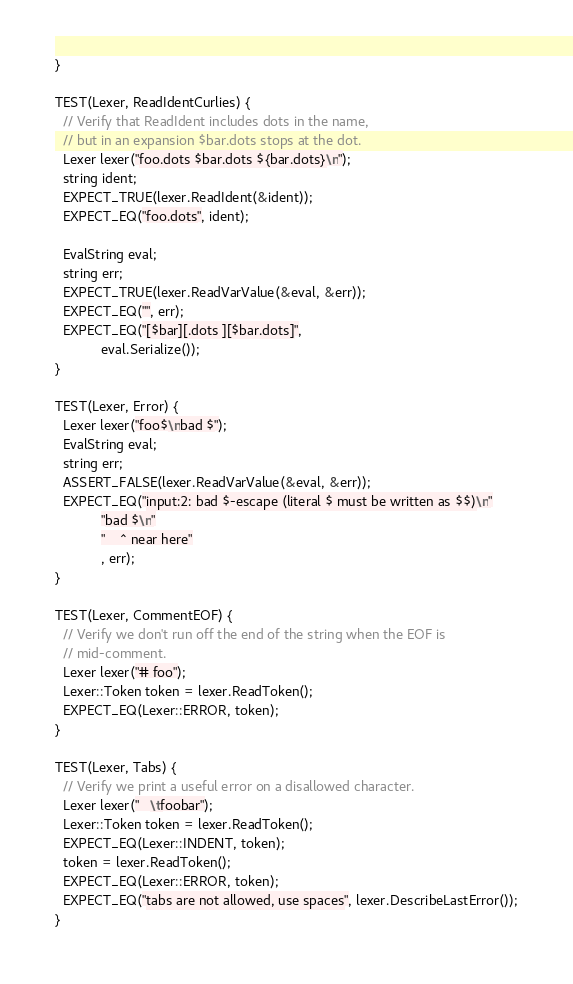Convert code to text. <code><loc_0><loc_0><loc_500><loc_500><_C++_>}

TEST(Lexer, ReadIdentCurlies) {
  // Verify that ReadIdent includes dots in the name,
  // but in an expansion $bar.dots stops at the dot.
  Lexer lexer("foo.dots $bar.dots ${bar.dots}\n");
  string ident;
  EXPECT_TRUE(lexer.ReadIdent(&ident));
  EXPECT_EQ("foo.dots", ident);

  EvalString eval;
  string err;
  EXPECT_TRUE(lexer.ReadVarValue(&eval, &err));
  EXPECT_EQ("", err);
  EXPECT_EQ("[$bar][.dots ][$bar.dots]",
            eval.Serialize());
}

TEST(Lexer, Error) {
  Lexer lexer("foo$\nbad $");
  EvalString eval;
  string err;
  ASSERT_FALSE(lexer.ReadVarValue(&eval, &err));
  EXPECT_EQ("input:2: bad $-escape (literal $ must be written as $$)\n"
            "bad $\n"
            "    ^ near here"
            , err);
}

TEST(Lexer, CommentEOF) {
  // Verify we don't run off the end of the string when the EOF is
  // mid-comment.
  Lexer lexer("# foo");
  Lexer::Token token = lexer.ReadToken();
  EXPECT_EQ(Lexer::ERROR, token);
}

TEST(Lexer, Tabs) {
  // Verify we print a useful error on a disallowed character.
  Lexer lexer("   \tfoobar");
  Lexer::Token token = lexer.ReadToken();
  EXPECT_EQ(Lexer::INDENT, token);
  token = lexer.ReadToken();
  EXPECT_EQ(Lexer::ERROR, token);
  EXPECT_EQ("tabs are not allowed, use spaces", lexer.DescribeLastError());
}
</code> 